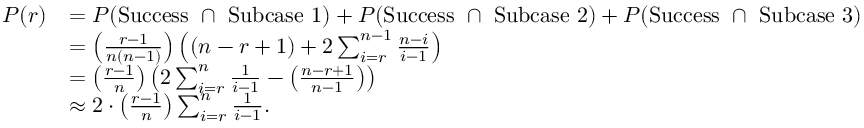<formula> <loc_0><loc_0><loc_500><loc_500>\begin{array} { r l } { P ( r ) } & { = P ( S u c c e s s \cap S u b c a s e 1 ) + P ( S u c c e s s \cap S u b c a s e 2 ) + P ( S u c c e s s \cap S u b c a s e 3 ) } \\ & { = \left ( \frac { r - 1 } { n ( n - 1 ) } \right ) \left ( ( n - r + 1 ) + 2 \sum _ { i = r } ^ { n - 1 } \frac { n - i } { i - 1 } \right ) } \\ & { = \left ( \frac { r - 1 } { n } \right ) \left ( 2 \sum _ { i = r } ^ { n } \frac { 1 } { i - 1 } - \left ( \frac { n - r + 1 } { n - 1 } \right ) \right ) } \\ & { \approx 2 \cdot \left ( \frac { r - 1 } { n } \right ) \sum _ { i = r } ^ { n } \frac { 1 } { i - 1 } . } \end{array}</formula> 